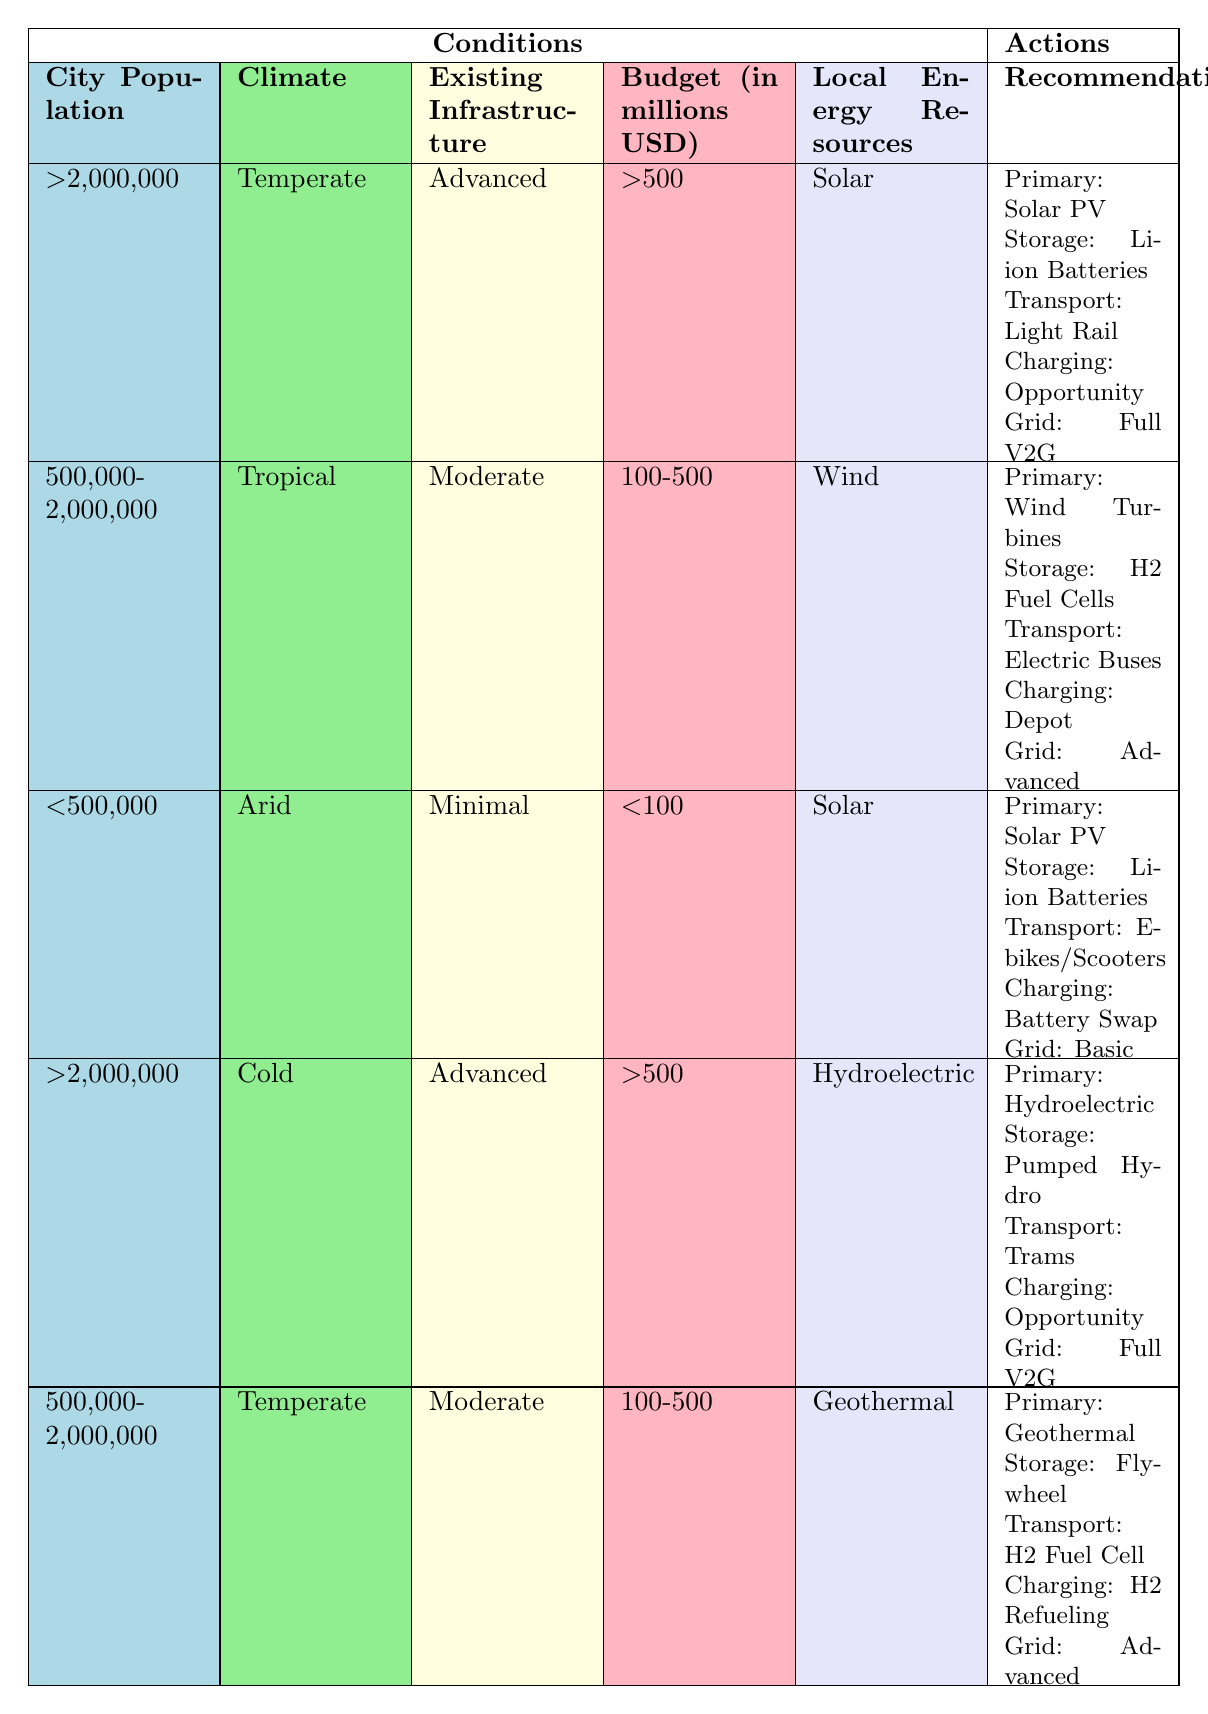What is the primary energy source recommended for a city with a population over 2,000,000 in a temperate climate? The table indicates that for a city with a population greater than 2,000,000 and in a temperate climate, the primary energy source recommended is Solar PV. This is found in the first row of the table.
Answer: Solar PV Which transportation mode is suggested for a city with a tropical climate and moderate existing infrastructure? Based on the table, the transportation mode suggested for a city with a tropical climate and moderate existing infrastructure is Electric Buses, as indicated in the second row.
Answer: Electric Buses Are hydrogen fuel cells recommended for cities with a budget of over 500 million USD? To answer this question, we look for entries in the table where the budget exceeds 500 million USD. The rows show that hydrogen fuel cells are suggested for a moderate budget option but not for the higher budget option, thus the statement is false.
Answer: No What energy storage solution is recommended for cities with minimal existing infrastructure and an arid climate? Referring to the table, for a city with minimal infrastructure and an arid climate, the recommended energy storage solution is Li-ion Batteries, as shown in the third row.
Answer: Li-ion Batteries Identify the charging infrastructure suggested for cities with existing infrastructure rated as advanced and local energy resources as hydroelectric. The table shows that for a city with advanced existing infrastructure and hydroelectric resources, the suggested charging infrastructure is Opportunity Charging, as noted in the fourth row.
Answer: Opportunity Charging What transportation modes are recommended across all city populations in the table? By examining the transportation modes listed in the table, we can see that Light Rail, Electric Buses, E-bikes and Scooters, Trams, and Hydrogen Fuel Cell Vehicles are all suggested across different populations. There are five different modes presented total.
Answer: Five modes If the budget for a city is less than 100 million USD, how many charging infrastructure options are there based on the rules in the table? Looking at the third row of the table, the charging infrastructure option for cities with a budget of less than 100 million USD is Battery Swapping. Therefore, there is only one charging infrastructure option available in this scenario.
Answer: One option What is the average budget range indicated for cities that recommend geothermal energy as the primary source? From the table, geothermal energy is recommended for a city with a moderate budget (100-500 million USD). Since this is the only entry for geothermal, the average is the range itself, which is 100-500 million USD.
Answer: 100-500 million USD For a city with a population under 500,000 and utilizing solar as a local energy resource, what actions are recommended? The table specifies that for a city below 500,000, using solar energy, the recommended actions include Solar PV as the primary energy source, Li-ion Batteries for storage, E-bikes and Scooters for transportation, Battery Swapping for charging infrastructure, and Basic Smart Grid Integration. This is indicated in the third row.
Answer: Multiple actions listed above 